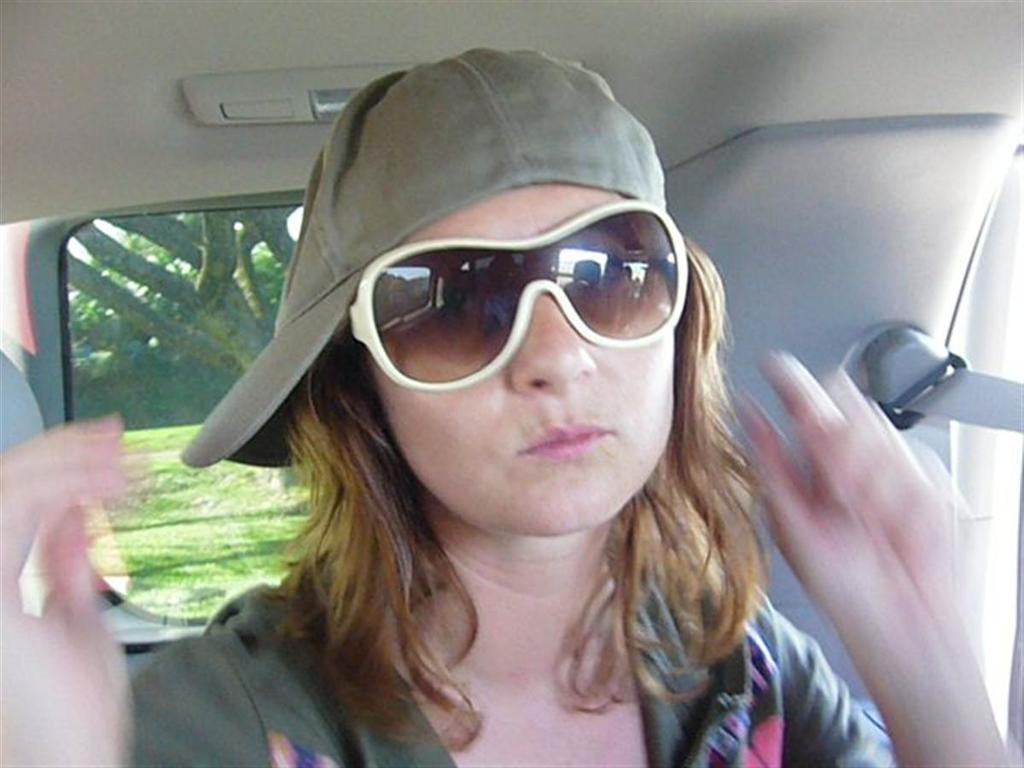Where was the image taken? The image was taken inside a car. Who is the main subject in the image? There is a woman in the middle of the image. What is the woman wearing on her face? The woman is wearing goggles. What else is the woman wearing on her head? The woman is wearing a cap. What level of pleasure does the woman in the image seem to be experiencing? The image does not provide any information about the woman's level of pleasure, so it cannot be determined from the image. 